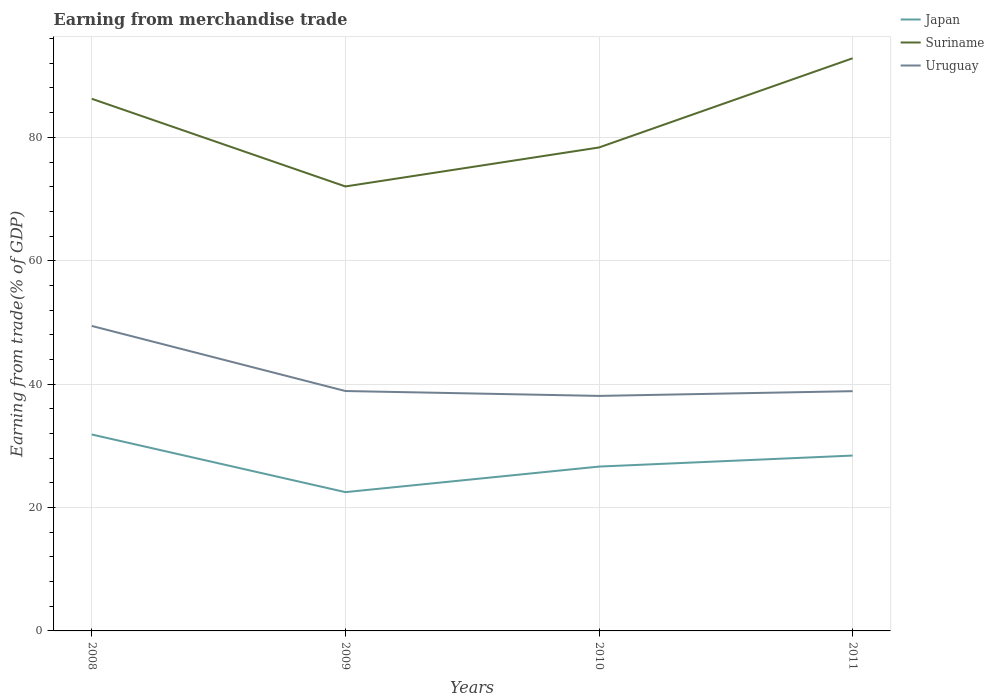Does the line corresponding to Uruguay intersect with the line corresponding to Suriname?
Provide a short and direct response. No. Is the number of lines equal to the number of legend labels?
Offer a very short reply. Yes. Across all years, what is the maximum earnings from trade in Suriname?
Provide a short and direct response. 72.04. What is the total earnings from trade in Suriname in the graph?
Give a very brief answer. -14.46. What is the difference between the highest and the second highest earnings from trade in Uruguay?
Ensure brevity in your answer.  11.34. Is the earnings from trade in Japan strictly greater than the earnings from trade in Uruguay over the years?
Offer a very short reply. Yes. How many lines are there?
Offer a very short reply. 3. Does the graph contain any zero values?
Offer a very short reply. No. Does the graph contain grids?
Offer a very short reply. Yes. Where does the legend appear in the graph?
Ensure brevity in your answer.  Top right. How are the legend labels stacked?
Make the answer very short. Vertical. What is the title of the graph?
Keep it short and to the point. Earning from merchandise trade. What is the label or title of the Y-axis?
Your answer should be compact. Earning from trade(% of GDP). What is the Earning from trade(% of GDP) in Japan in 2008?
Provide a succinct answer. 31.84. What is the Earning from trade(% of GDP) of Suriname in 2008?
Your answer should be compact. 86.25. What is the Earning from trade(% of GDP) in Uruguay in 2008?
Your response must be concise. 49.43. What is the Earning from trade(% of GDP) of Japan in 2009?
Offer a very short reply. 22.5. What is the Earning from trade(% of GDP) of Suriname in 2009?
Make the answer very short. 72.04. What is the Earning from trade(% of GDP) of Uruguay in 2009?
Provide a short and direct response. 38.89. What is the Earning from trade(% of GDP) of Japan in 2010?
Offer a terse response. 26.64. What is the Earning from trade(% of GDP) in Suriname in 2010?
Provide a short and direct response. 78.36. What is the Earning from trade(% of GDP) in Uruguay in 2010?
Give a very brief answer. 38.09. What is the Earning from trade(% of GDP) of Japan in 2011?
Your response must be concise. 28.42. What is the Earning from trade(% of GDP) in Suriname in 2011?
Offer a very short reply. 92.82. What is the Earning from trade(% of GDP) of Uruguay in 2011?
Ensure brevity in your answer.  38.86. Across all years, what is the maximum Earning from trade(% of GDP) of Japan?
Your answer should be compact. 31.84. Across all years, what is the maximum Earning from trade(% of GDP) of Suriname?
Your answer should be compact. 92.82. Across all years, what is the maximum Earning from trade(% of GDP) of Uruguay?
Offer a very short reply. 49.43. Across all years, what is the minimum Earning from trade(% of GDP) in Japan?
Your answer should be very brief. 22.5. Across all years, what is the minimum Earning from trade(% of GDP) in Suriname?
Your answer should be very brief. 72.04. Across all years, what is the minimum Earning from trade(% of GDP) in Uruguay?
Your answer should be very brief. 38.09. What is the total Earning from trade(% of GDP) of Japan in the graph?
Give a very brief answer. 109.4. What is the total Earning from trade(% of GDP) in Suriname in the graph?
Make the answer very short. 329.47. What is the total Earning from trade(% of GDP) of Uruguay in the graph?
Your answer should be very brief. 165.27. What is the difference between the Earning from trade(% of GDP) in Japan in 2008 and that in 2009?
Make the answer very short. 9.34. What is the difference between the Earning from trade(% of GDP) in Suriname in 2008 and that in 2009?
Make the answer very short. 14.21. What is the difference between the Earning from trade(% of GDP) of Uruguay in 2008 and that in 2009?
Your answer should be compact. 10.55. What is the difference between the Earning from trade(% of GDP) of Japan in 2008 and that in 2010?
Ensure brevity in your answer.  5.2. What is the difference between the Earning from trade(% of GDP) of Suriname in 2008 and that in 2010?
Provide a short and direct response. 7.89. What is the difference between the Earning from trade(% of GDP) in Uruguay in 2008 and that in 2010?
Offer a terse response. 11.34. What is the difference between the Earning from trade(% of GDP) in Japan in 2008 and that in 2011?
Offer a very short reply. 3.42. What is the difference between the Earning from trade(% of GDP) of Suriname in 2008 and that in 2011?
Offer a very short reply. -6.56. What is the difference between the Earning from trade(% of GDP) of Uruguay in 2008 and that in 2011?
Provide a short and direct response. 10.57. What is the difference between the Earning from trade(% of GDP) in Japan in 2009 and that in 2010?
Provide a short and direct response. -4.14. What is the difference between the Earning from trade(% of GDP) of Suriname in 2009 and that in 2010?
Provide a short and direct response. -6.32. What is the difference between the Earning from trade(% of GDP) of Uruguay in 2009 and that in 2010?
Your answer should be very brief. 0.79. What is the difference between the Earning from trade(% of GDP) in Japan in 2009 and that in 2011?
Provide a short and direct response. -5.93. What is the difference between the Earning from trade(% of GDP) of Suriname in 2009 and that in 2011?
Ensure brevity in your answer.  -20.78. What is the difference between the Earning from trade(% of GDP) in Uruguay in 2009 and that in 2011?
Provide a succinct answer. 0.03. What is the difference between the Earning from trade(% of GDP) of Japan in 2010 and that in 2011?
Provide a short and direct response. -1.79. What is the difference between the Earning from trade(% of GDP) of Suriname in 2010 and that in 2011?
Offer a terse response. -14.46. What is the difference between the Earning from trade(% of GDP) in Uruguay in 2010 and that in 2011?
Make the answer very short. -0.77. What is the difference between the Earning from trade(% of GDP) of Japan in 2008 and the Earning from trade(% of GDP) of Suriname in 2009?
Offer a very short reply. -40.2. What is the difference between the Earning from trade(% of GDP) of Japan in 2008 and the Earning from trade(% of GDP) of Uruguay in 2009?
Make the answer very short. -7.05. What is the difference between the Earning from trade(% of GDP) of Suriname in 2008 and the Earning from trade(% of GDP) of Uruguay in 2009?
Provide a succinct answer. 47.37. What is the difference between the Earning from trade(% of GDP) of Japan in 2008 and the Earning from trade(% of GDP) of Suriname in 2010?
Ensure brevity in your answer.  -46.52. What is the difference between the Earning from trade(% of GDP) of Japan in 2008 and the Earning from trade(% of GDP) of Uruguay in 2010?
Your answer should be compact. -6.25. What is the difference between the Earning from trade(% of GDP) in Suriname in 2008 and the Earning from trade(% of GDP) in Uruguay in 2010?
Provide a short and direct response. 48.16. What is the difference between the Earning from trade(% of GDP) in Japan in 2008 and the Earning from trade(% of GDP) in Suriname in 2011?
Your answer should be compact. -60.98. What is the difference between the Earning from trade(% of GDP) in Japan in 2008 and the Earning from trade(% of GDP) in Uruguay in 2011?
Your answer should be compact. -7.02. What is the difference between the Earning from trade(% of GDP) in Suriname in 2008 and the Earning from trade(% of GDP) in Uruguay in 2011?
Your response must be concise. 47.39. What is the difference between the Earning from trade(% of GDP) of Japan in 2009 and the Earning from trade(% of GDP) of Suriname in 2010?
Give a very brief answer. -55.86. What is the difference between the Earning from trade(% of GDP) in Japan in 2009 and the Earning from trade(% of GDP) in Uruguay in 2010?
Offer a very short reply. -15.6. What is the difference between the Earning from trade(% of GDP) in Suriname in 2009 and the Earning from trade(% of GDP) in Uruguay in 2010?
Make the answer very short. 33.95. What is the difference between the Earning from trade(% of GDP) in Japan in 2009 and the Earning from trade(% of GDP) in Suriname in 2011?
Provide a succinct answer. -70.32. What is the difference between the Earning from trade(% of GDP) of Japan in 2009 and the Earning from trade(% of GDP) of Uruguay in 2011?
Provide a short and direct response. -16.36. What is the difference between the Earning from trade(% of GDP) in Suriname in 2009 and the Earning from trade(% of GDP) in Uruguay in 2011?
Offer a very short reply. 33.18. What is the difference between the Earning from trade(% of GDP) of Japan in 2010 and the Earning from trade(% of GDP) of Suriname in 2011?
Make the answer very short. -66.18. What is the difference between the Earning from trade(% of GDP) of Japan in 2010 and the Earning from trade(% of GDP) of Uruguay in 2011?
Give a very brief answer. -12.22. What is the difference between the Earning from trade(% of GDP) of Suriname in 2010 and the Earning from trade(% of GDP) of Uruguay in 2011?
Your answer should be compact. 39.5. What is the average Earning from trade(% of GDP) in Japan per year?
Make the answer very short. 27.35. What is the average Earning from trade(% of GDP) in Suriname per year?
Offer a terse response. 82.37. What is the average Earning from trade(% of GDP) in Uruguay per year?
Keep it short and to the point. 41.32. In the year 2008, what is the difference between the Earning from trade(% of GDP) of Japan and Earning from trade(% of GDP) of Suriname?
Provide a short and direct response. -54.41. In the year 2008, what is the difference between the Earning from trade(% of GDP) in Japan and Earning from trade(% of GDP) in Uruguay?
Ensure brevity in your answer.  -17.59. In the year 2008, what is the difference between the Earning from trade(% of GDP) of Suriname and Earning from trade(% of GDP) of Uruguay?
Give a very brief answer. 36.82. In the year 2009, what is the difference between the Earning from trade(% of GDP) in Japan and Earning from trade(% of GDP) in Suriname?
Offer a very short reply. -49.55. In the year 2009, what is the difference between the Earning from trade(% of GDP) in Japan and Earning from trade(% of GDP) in Uruguay?
Keep it short and to the point. -16.39. In the year 2009, what is the difference between the Earning from trade(% of GDP) of Suriname and Earning from trade(% of GDP) of Uruguay?
Keep it short and to the point. 33.16. In the year 2010, what is the difference between the Earning from trade(% of GDP) in Japan and Earning from trade(% of GDP) in Suriname?
Ensure brevity in your answer.  -51.72. In the year 2010, what is the difference between the Earning from trade(% of GDP) of Japan and Earning from trade(% of GDP) of Uruguay?
Provide a short and direct response. -11.46. In the year 2010, what is the difference between the Earning from trade(% of GDP) in Suriname and Earning from trade(% of GDP) in Uruguay?
Your response must be concise. 40.27. In the year 2011, what is the difference between the Earning from trade(% of GDP) of Japan and Earning from trade(% of GDP) of Suriname?
Offer a terse response. -64.4. In the year 2011, what is the difference between the Earning from trade(% of GDP) in Japan and Earning from trade(% of GDP) in Uruguay?
Keep it short and to the point. -10.44. In the year 2011, what is the difference between the Earning from trade(% of GDP) in Suriname and Earning from trade(% of GDP) in Uruguay?
Your answer should be compact. 53.96. What is the ratio of the Earning from trade(% of GDP) of Japan in 2008 to that in 2009?
Provide a short and direct response. 1.42. What is the ratio of the Earning from trade(% of GDP) of Suriname in 2008 to that in 2009?
Make the answer very short. 1.2. What is the ratio of the Earning from trade(% of GDP) of Uruguay in 2008 to that in 2009?
Offer a terse response. 1.27. What is the ratio of the Earning from trade(% of GDP) of Japan in 2008 to that in 2010?
Offer a terse response. 1.2. What is the ratio of the Earning from trade(% of GDP) in Suriname in 2008 to that in 2010?
Your response must be concise. 1.1. What is the ratio of the Earning from trade(% of GDP) in Uruguay in 2008 to that in 2010?
Make the answer very short. 1.3. What is the ratio of the Earning from trade(% of GDP) of Japan in 2008 to that in 2011?
Ensure brevity in your answer.  1.12. What is the ratio of the Earning from trade(% of GDP) in Suriname in 2008 to that in 2011?
Offer a terse response. 0.93. What is the ratio of the Earning from trade(% of GDP) in Uruguay in 2008 to that in 2011?
Your answer should be compact. 1.27. What is the ratio of the Earning from trade(% of GDP) of Japan in 2009 to that in 2010?
Provide a succinct answer. 0.84. What is the ratio of the Earning from trade(% of GDP) in Suriname in 2009 to that in 2010?
Make the answer very short. 0.92. What is the ratio of the Earning from trade(% of GDP) in Uruguay in 2009 to that in 2010?
Make the answer very short. 1.02. What is the ratio of the Earning from trade(% of GDP) of Japan in 2009 to that in 2011?
Your answer should be compact. 0.79. What is the ratio of the Earning from trade(% of GDP) in Suriname in 2009 to that in 2011?
Give a very brief answer. 0.78. What is the ratio of the Earning from trade(% of GDP) in Japan in 2010 to that in 2011?
Provide a succinct answer. 0.94. What is the ratio of the Earning from trade(% of GDP) of Suriname in 2010 to that in 2011?
Keep it short and to the point. 0.84. What is the ratio of the Earning from trade(% of GDP) in Uruguay in 2010 to that in 2011?
Make the answer very short. 0.98. What is the difference between the highest and the second highest Earning from trade(% of GDP) in Japan?
Your response must be concise. 3.42. What is the difference between the highest and the second highest Earning from trade(% of GDP) of Suriname?
Make the answer very short. 6.56. What is the difference between the highest and the second highest Earning from trade(% of GDP) in Uruguay?
Make the answer very short. 10.55. What is the difference between the highest and the lowest Earning from trade(% of GDP) of Japan?
Offer a very short reply. 9.34. What is the difference between the highest and the lowest Earning from trade(% of GDP) in Suriname?
Your answer should be compact. 20.78. What is the difference between the highest and the lowest Earning from trade(% of GDP) in Uruguay?
Offer a terse response. 11.34. 